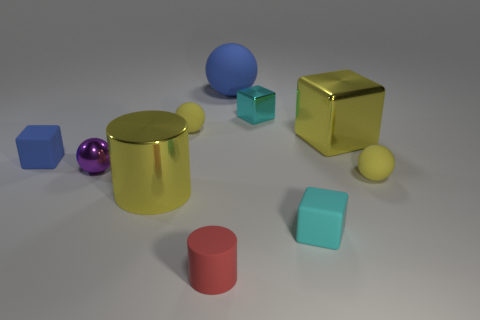Are there any small shiny blocks left of the small rubber cylinder on the left side of the cyan cube that is in front of the tiny cyan metal thing?
Your answer should be compact. No. What number of matte things are either blue cylinders or small purple objects?
Ensure brevity in your answer.  0. Do the rubber cylinder and the tiny metallic block have the same color?
Give a very brief answer. No. There is a big cylinder; what number of small balls are on the left side of it?
Make the answer very short. 1. How many yellow spheres are both to the right of the small cylinder and behind the small blue rubber object?
Keep it short and to the point. 0. What is the shape of the cyan object that is the same material as the large yellow cylinder?
Your response must be concise. Cube. Do the purple sphere to the left of the big sphere and the rubber block that is to the left of the yellow shiny cylinder have the same size?
Give a very brief answer. Yes. There is a small rubber block in front of the tiny blue matte block; what color is it?
Give a very brief answer. Cyan. What is the material of the purple sphere that is in front of the large metallic block that is behind the tiny purple ball?
Give a very brief answer. Metal. The small purple metallic object has what shape?
Give a very brief answer. Sphere. 